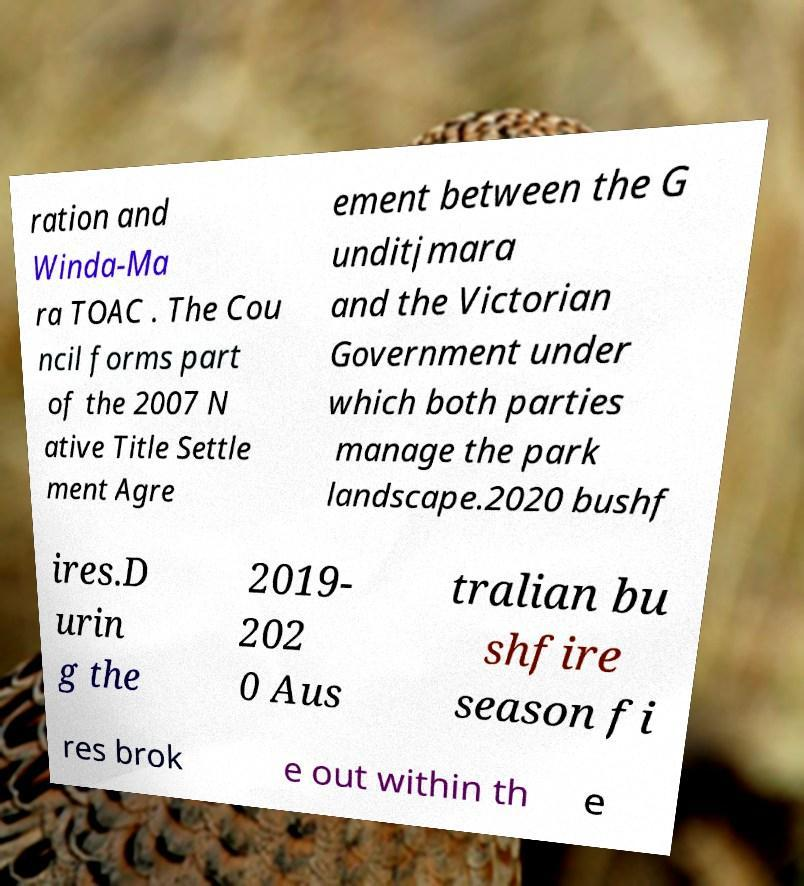Could you assist in decoding the text presented in this image and type it out clearly? ration and Winda-Ma ra TOAC . The Cou ncil forms part of the 2007 N ative Title Settle ment Agre ement between the G unditjmara and the Victorian Government under which both parties manage the park landscape.2020 bushf ires.D urin g the 2019- 202 0 Aus tralian bu shfire season fi res brok e out within th e 